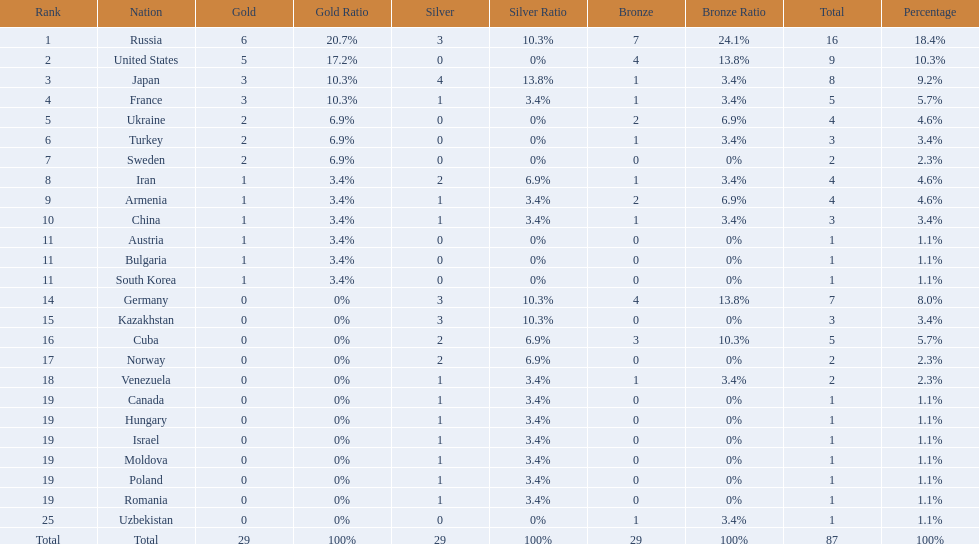Japan and france each won how many gold medals? 3. 